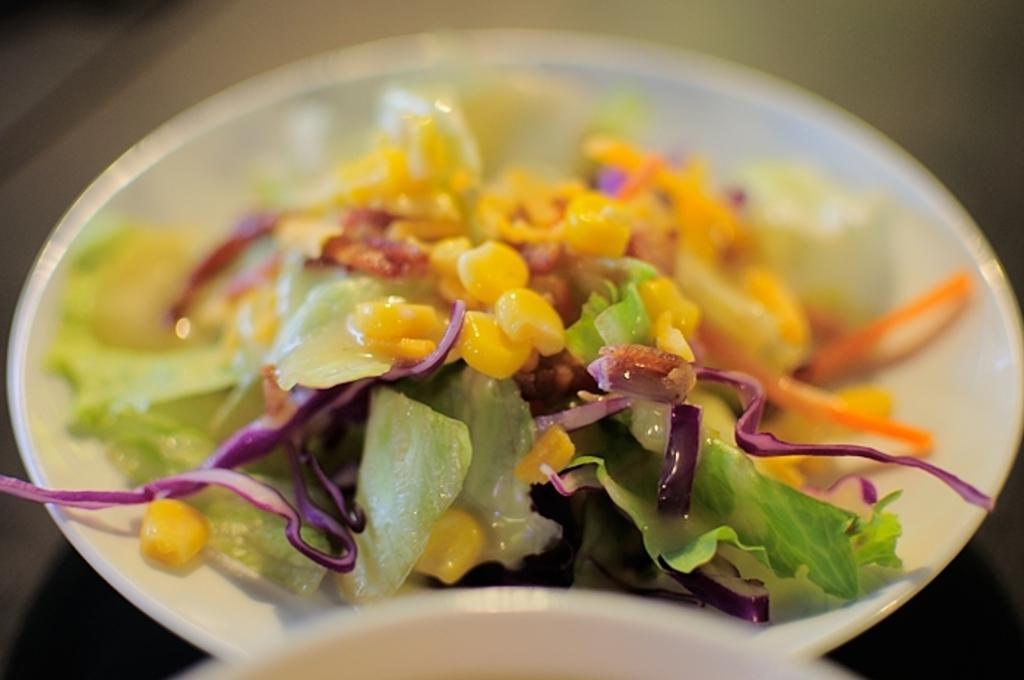How would you summarize this image in a sentence or two? In this image we can see a plate with some food item. 